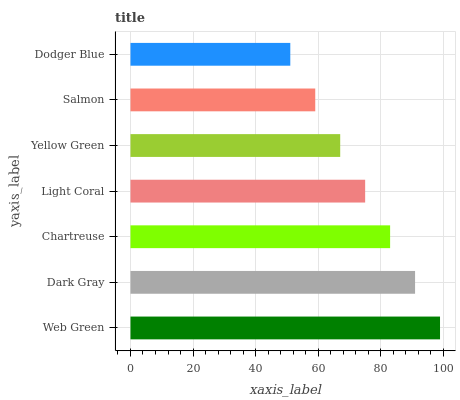Is Dodger Blue the minimum?
Answer yes or no. Yes. Is Web Green the maximum?
Answer yes or no. Yes. Is Dark Gray the minimum?
Answer yes or no. No. Is Dark Gray the maximum?
Answer yes or no. No. Is Web Green greater than Dark Gray?
Answer yes or no. Yes. Is Dark Gray less than Web Green?
Answer yes or no. Yes. Is Dark Gray greater than Web Green?
Answer yes or no. No. Is Web Green less than Dark Gray?
Answer yes or no. No. Is Light Coral the high median?
Answer yes or no. Yes. Is Light Coral the low median?
Answer yes or no. Yes. Is Web Green the high median?
Answer yes or no. No. Is Dark Gray the low median?
Answer yes or no. No. 